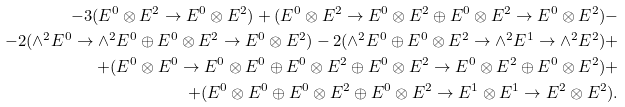<formula> <loc_0><loc_0><loc_500><loc_500>- 3 ( E ^ { 0 } \otimes E ^ { 2 } \rightarrow E ^ { 0 } \otimes E ^ { 2 } ) + ( E ^ { 0 } \otimes E ^ { 2 } \rightarrow E ^ { 0 } \otimes E ^ { 2 } \oplus E ^ { 0 } \otimes E ^ { 2 } \rightarrow E ^ { 0 } \otimes E ^ { 2 } ) - \\ - 2 ( \wedge ^ { 2 } E ^ { 0 } \rightarrow \wedge ^ { 2 } E ^ { 0 } \oplus E ^ { 0 } \otimes E ^ { 2 } \rightarrow E ^ { 0 } \otimes E ^ { 2 } ) - 2 ( \wedge ^ { 2 } E ^ { 0 } \oplus E ^ { 0 } \otimes E ^ { 2 } \rightarrow \wedge ^ { 2 } E ^ { 1 } \rightarrow \wedge ^ { 2 } E ^ { 2 } ) + \\ + ( E ^ { 0 } \otimes E ^ { 0 } \rightarrow E ^ { 0 } \otimes E ^ { 0 } \oplus E ^ { 0 } \otimes E ^ { 2 } \oplus E ^ { 0 } \otimes E ^ { 2 } \rightarrow E ^ { 0 } \otimes E ^ { 2 } \oplus E ^ { 0 } \otimes E ^ { 2 } ) + \\ + ( E ^ { 0 } \otimes E ^ { 0 } \oplus E ^ { 0 } \otimes E ^ { 2 } \oplus E ^ { 0 } \otimes E ^ { 2 } \rightarrow E ^ { 1 } \otimes E ^ { 1 } \rightarrow E ^ { 2 } \otimes E ^ { 2 } ) .</formula> 